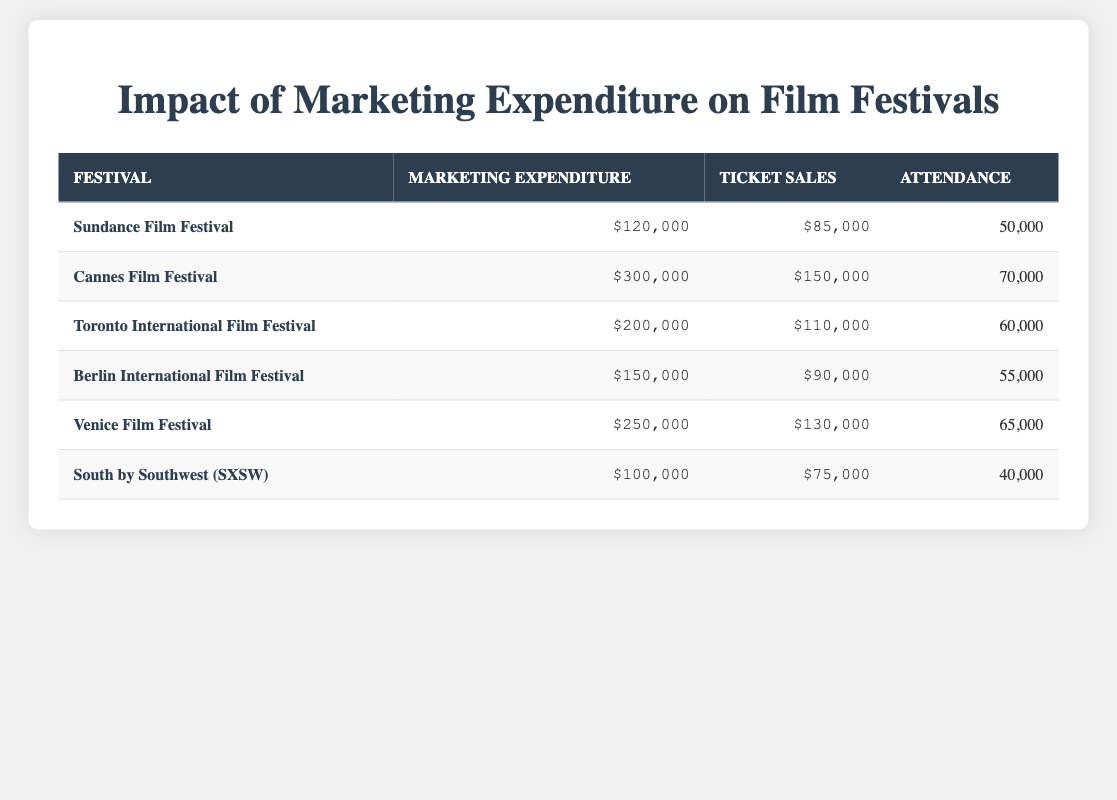What is the marketing expenditure for the Cannes Film Festival? The table lists the marketing expenditure for each festival. For the Cannes Film Festival, it is shown as $300,000.
Answer: $300,000 Which festival has the highest ticket sales? By comparing the ticket sales values in the table, Cannes Film Festival has the highest ticket sales of $150,000.
Answer: $150,000 What is the average attendance across all listed film festivals? First, we sum the attendance values: 50000 + 70000 + 60000 + 55000 + 65000 + 40000 = 400000. There are 6 festivals, so the average attendance is 400000 / 6 = 66666.67, approximately 66667 when rounded.
Answer: 66667 Is the marketing expenditure for the South by Southwest (SXSW) greater than the marketing expenditure for the Berlin International Film Festival? The marketing expenditure for SXSW is $100,000 while for Berlin International Film Festival, it is $150,000. Thus, $100,000 is not greater than $150,000, making the statement false.
Answer: No Which festival has the lowest attendance, and what is the attendance value? Looking through the attendance values, South by Southwest (SXSW) has the lowest attendance of 40,000.
Answer: 40,000 What is the difference in ticket sales between the Venice Film Festival and the Toronto International Film Festival? Ticket sales for Venice Film Festival is $130,000, and for Toronto International Film Festival, it is $110,000. The difference is $130,000 - $110,000 = $20,000.
Answer: $20,000 Does an increase in marketing expenditure correlate with an increase in ticket sales? To assess the correlation, we look for a trend in the table. Notably, as the marketing expenditure rises, ticket sales do indeed increase in most cases (e.g., Cannes and Venice). Thus, it can be reasonably concluded that higher marketing spending tends to align with higher ticket sales.
Answer: Yes What is the total marketing expenditure for all listed festivals? The marketing expenditures are summed up: $120,000 + $300,000 + $200,000 + $150,000 + $250,000 + $100,000 = $1,120,000.
Answer: $1,120,000 